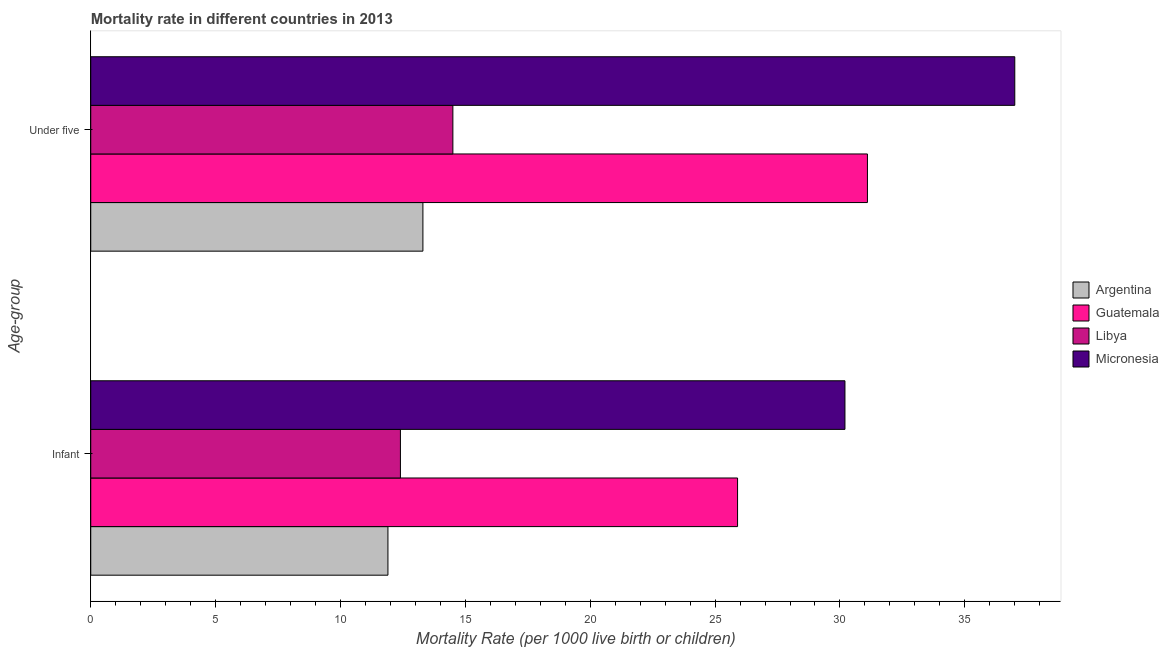How many bars are there on the 2nd tick from the top?
Keep it short and to the point. 4. What is the label of the 1st group of bars from the top?
Ensure brevity in your answer.  Under five. What is the infant mortality rate in Micronesia?
Provide a succinct answer. 30.2. Across all countries, what is the minimum under-5 mortality rate?
Keep it short and to the point. 13.3. In which country was the under-5 mortality rate maximum?
Keep it short and to the point. Micronesia. What is the total under-5 mortality rate in the graph?
Offer a terse response. 95.9. What is the difference between the infant mortality rate in Guatemala and that in Argentina?
Make the answer very short. 14. What is the difference between the under-5 mortality rate in Argentina and the infant mortality rate in Libya?
Your response must be concise. 0.9. What is the average under-5 mortality rate per country?
Make the answer very short. 23.98. What is the difference between the infant mortality rate and under-5 mortality rate in Argentina?
Your answer should be very brief. -1.4. In how many countries, is the infant mortality rate greater than 25 ?
Provide a succinct answer. 2. What is the ratio of the under-5 mortality rate in Libya to that in Argentina?
Provide a short and direct response. 1.09. Is the infant mortality rate in Argentina less than that in Micronesia?
Provide a succinct answer. Yes. In how many countries, is the infant mortality rate greater than the average infant mortality rate taken over all countries?
Offer a very short reply. 2. What does the 3rd bar from the top in Infant represents?
Offer a terse response. Guatemala. What does the 2nd bar from the bottom in Infant represents?
Your answer should be very brief. Guatemala. What is the difference between two consecutive major ticks on the X-axis?
Keep it short and to the point. 5. Where does the legend appear in the graph?
Your response must be concise. Center right. How many legend labels are there?
Offer a terse response. 4. How are the legend labels stacked?
Provide a short and direct response. Vertical. What is the title of the graph?
Make the answer very short. Mortality rate in different countries in 2013. Does "Cabo Verde" appear as one of the legend labels in the graph?
Provide a succinct answer. No. What is the label or title of the X-axis?
Ensure brevity in your answer.  Mortality Rate (per 1000 live birth or children). What is the label or title of the Y-axis?
Provide a succinct answer. Age-group. What is the Mortality Rate (per 1000 live birth or children) in Argentina in Infant?
Your response must be concise. 11.9. What is the Mortality Rate (per 1000 live birth or children) of Guatemala in Infant?
Your answer should be very brief. 25.9. What is the Mortality Rate (per 1000 live birth or children) of Micronesia in Infant?
Provide a short and direct response. 30.2. What is the Mortality Rate (per 1000 live birth or children) of Guatemala in Under five?
Give a very brief answer. 31.1. Across all Age-group, what is the maximum Mortality Rate (per 1000 live birth or children) of Guatemala?
Your answer should be compact. 31.1. Across all Age-group, what is the minimum Mortality Rate (per 1000 live birth or children) of Guatemala?
Offer a terse response. 25.9. Across all Age-group, what is the minimum Mortality Rate (per 1000 live birth or children) of Libya?
Provide a succinct answer. 12.4. Across all Age-group, what is the minimum Mortality Rate (per 1000 live birth or children) in Micronesia?
Offer a very short reply. 30.2. What is the total Mortality Rate (per 1000 live birth or children) of Argentina in the graph?
Your response must be concise. 25.2. What is the total Mortality Rate (per 1000 live birth or children) of Libya in the graph?
Provide a succinct answer. 26.9. What is the total Mortality Rate (per 1000 live birth or children) of Micronesia in the graph?
Offer a terse response. 67.2. What is the difference between the Mortality Rate (per 1000 live birth or children) in Libya in Infant and that in Under five?
Your answer should be very brief. -2.1. What is the difference between the Mortality Rate (per 1000 live birth or children) in Argentina in Infant and the Mortality Rate (per 1000 live birth or children) in Guatemala in Under five?
Offer a terse response. -19.2. What is the difference between the Mortality Rate (per 1000 live birth or children) in Argentina in Infant and the Mortality Rate (per 1000 live birth or children) in Micronesia in Under five?
Your answer should be very brief. -25.1. What is the difference between the Mortality Rate (per 1000 live birth or children) in Libya in Infant and the Mortality Rate (per 1000 live birth or children) in Micronesia in Under five?
Give a very brief answer. -24.6. What is the average Mortality Rate (per 1000 live birth or children) in Libya per Age-group?
Your answer should be compact. 13.45. What is the average Mortality Rate (per 1000 live birth or children) of Micronesia per Age-group?
Ensure brevity in your answer.  33.6. What is the difference between the Mortality Rate (per 1000 live birth or children) of Argentina and Mortality Rate (per 1000 live birth or children) of Guatemala in Infant?
Your answer should be very brief. -14. What is the difference between the Mortality Rate (per 1000 live birth or children) of Argentina and Mortality Rate (per 1000 live birth or children) of Micronesia in Infant?
Your response must be concise. -18.3. What is the difference between the Mortality Rate (per 1000 live birth or children) in Libya and Mortality Rate (per 1000 live birth or children) in Micronesia in Infant?
Ensure brevity in your answer.  -17.8. What is the difference between the Mortality Rate (per 1000 live birth or children) in Argentina and Mortality Rate (per 1000 live birth or children) in Guatemala in Under five?
Your response must be concise. -17.8. What is the difference between the Mortality Rate (per 1000 live birth or children) in Argentina and Mortality Rate (per 1000 live birth or children) in Libya in Under five?
Offer a very short reply. -1.2. What is the difference between the Mortality Rate (per 1000 live birth or children) in Argentina and Mortality Rate (per 1000 live birth or children) in Micronesia in Under five?
Provide a succinct answer. -23.7. What is the difference between the Mortality Rate (per 1000 live birth or children) in Libya and Mortality Rate (per 1000 live birth or children) in Micronesia in Under five?
Your response must be concise. -22.5. What is the ratio of the Mortality Rate (per 1000 live birth or children) of Argentina in Infant to that in Under five?
Keep it short and to the point. 0.89. What is the ratio of the Mortality Rate (per 1000 live birth or children) in Guatemala in Infant to that in Under five?
Offer a terse response. 0.83. What is the ratio of the Mortality Rate (per 1000 live birth or children) of Libya in Infant to that in Under five?
Offer a terse response. 0.86. What is the ratio of the Mortality Rate (per 1000 live birth or children) of Micronesia in Infant to that in Under five?
Give a very brief answer. 0.82. What is the difference between the highest and the second highest Mortality Rate (per 1000 live birth or children) of Argentina?
Keep it short and to the point. 1.4. What is the difference between the highest and the second highest Mortality Rate (per 1000 live birth or children) in Guatemala?
Ensure brevity in your answer.  5.2. What is the difference between the highest and the second highest Mortality Rate (per 1000 live birth or children) in Libya?
Give a very brief answer. 2.1. What is the difference between the highest and the lowest Mortality Rate (per 1000 live birth or children) in Argentina?
Keep it short and to the point. 1.4. What is the difference between the highest and the lowest Mortality Rate (per 1000 live birth or children) of Guatemala?
Provide a succinct answer. 5.2. What is the difference between the highest and the lowest Mortality Rate (per 1000 live birth or children) of Libya?
Give a very brief answer. 2.1. 